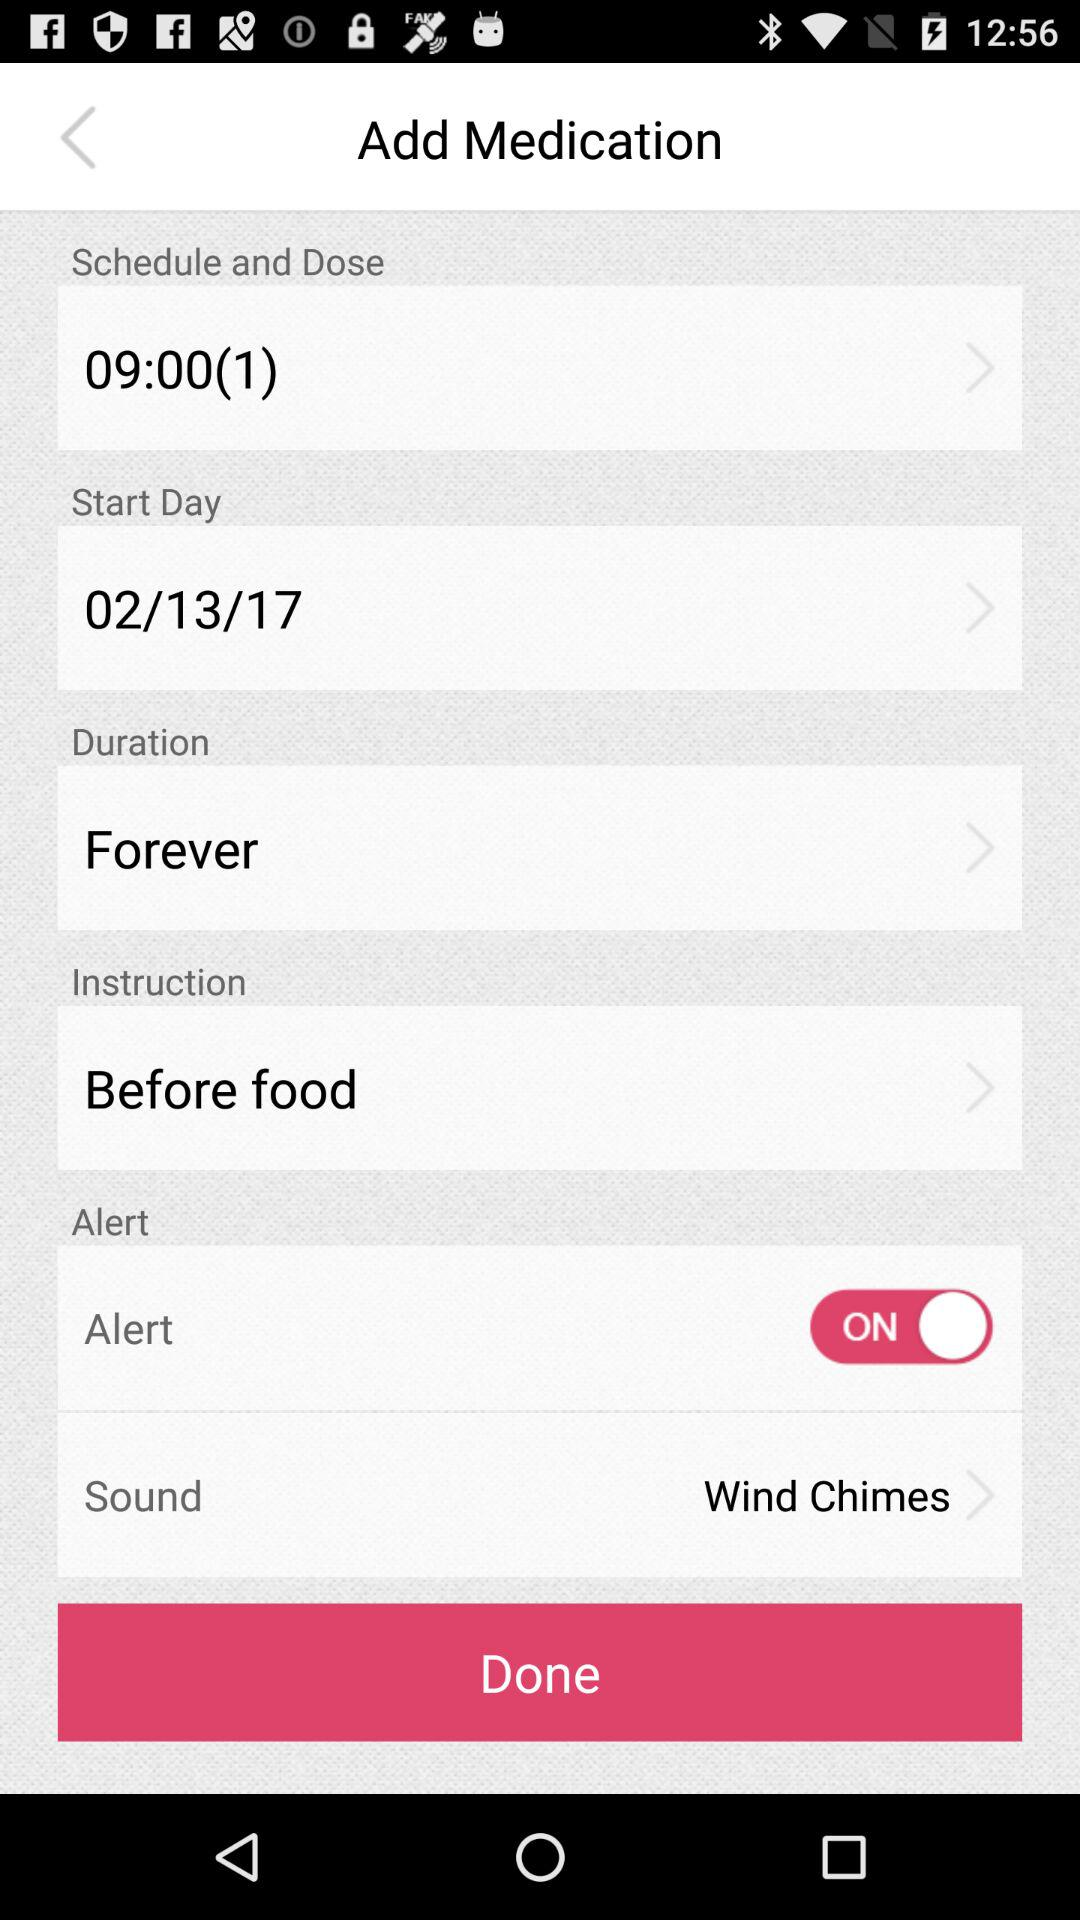What is the start day? The start day is February 13, 2017. 